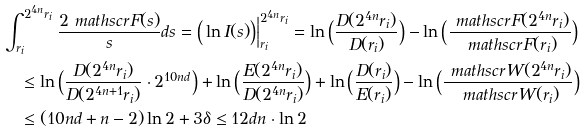Convert formula to latex. <formula><loc_0><loc_0><loc_500><loc_500>& \int _ { r _ { i } } ^ { 2 ^ { 4 n } r _ { i } } \frac { 2 \ m a t h s c r { F } ( s ) } { s } d s = \Big ( \ln I ( s ) \Big ) \Big | _ { r _ { i } } ^ { 2 ^ { 4 n } r _ { i } } = \ln \Big ( \frac { D ( 2 ^ { 4 n } r _ { i } ) } { D ( r _ { i } ) } \Big ) - \ln \Big ( \frac { \ m a t h s c r { F } ( 2 ^ { 4 n } r _ { i } ) } { \ m a t h s c r { F } ( r _ { i } ) } \Big ) \\ & \quad \leq \ln \Big ( \frac { D ( 2 ^ { 4 n } r _ { i } ) } { D ( 2 ^ { 4 n + 1 } r _ { i } ) } \cdot 2 ^ { 1 0 n d } \Big ) + \ln \Big ( \frac { E ( 2 ^ { 4 n } r _ { i } ) } { D ( 2 ^ { 4 n } r _ { i } ) } \Big ) + \ln \Big ( \frac { D ( r _ { i } ) } { E ( r _ { i } ) } \Big ) - \ln \Big ( \frac { \ m a t h s c r { W } ( 2 ^ { 4 n } r _ { i } ) } { \ m a t h s c r { W } ( r _ { i } ) } \Big ) \\ & \quad \leq ( 1 0 n d + n - 2 ) \ln 2 + 3 \delta \leq 1 2 d n \cdot \ln 2</formula> 